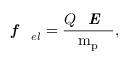Convert formula to latex. <formula><loc_0><loc_0><loc_500><loc_500>f _ { e l } = \frac { Q E } { m _ { p } } ,</formula> 